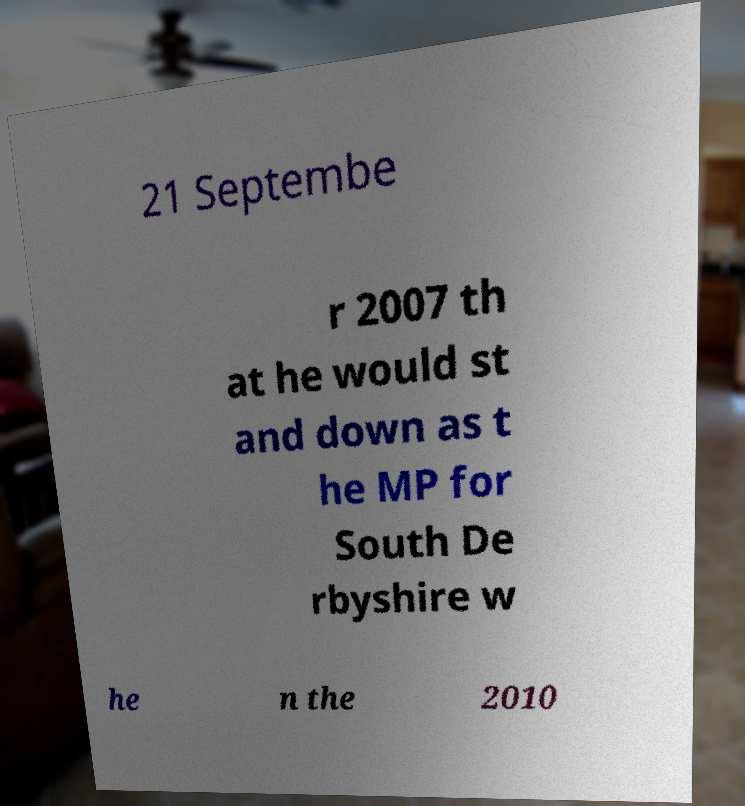There's text embedded in this image that I need extracted. Can you transcribe it verbatim? 21 Septembe r 2007 th at he would st and down as t he MP for South De rbyshire w he n the 2010 